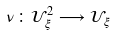Convert formula to latex. <formula><loc_0><loc_0><loc_500><loc_500>\nu \colon \mathcal { U } _ { \xi } ^ { 2 } \longrightarrow \mathcal { U } _ { \xi }</formula> 